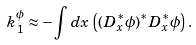Convert formula to latex. <formula><loc_0><loc_0><loc_500><loc_500>k _ { 1 } ^ { \phi } \approx - \int d x \, \left ( ( D _ { x } ^ { * } \phi ) ^ { * } D _ { x } ^ { * } \phi \right ) .</formula> 